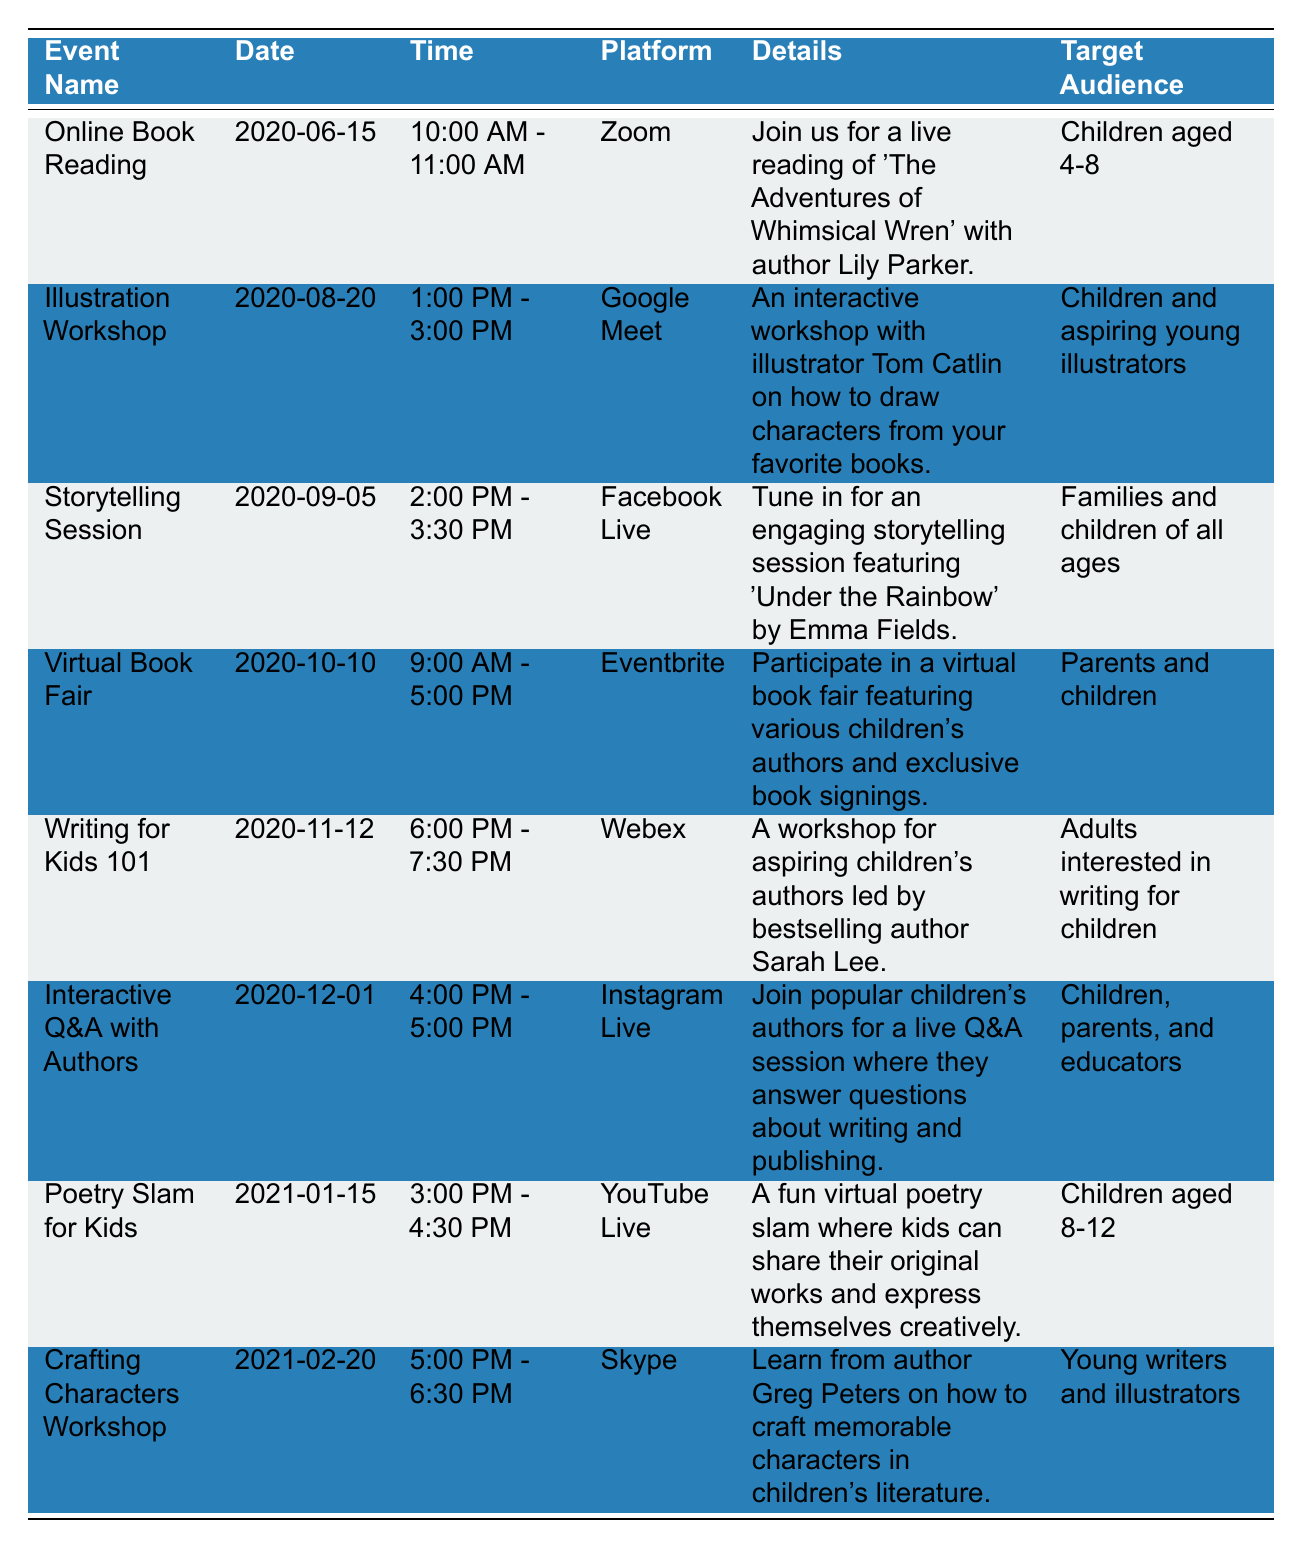What is the date of the Online Book Reading event? The table lists the Online Book Reading event under the Date column, showing the date as 2020-06-15.
Answer: 2020-06-15 How long is the Illustration Workshop scheduled to last? The time for the Illustration Workshop is from 1:00 PM to 3:00 PM, which is a duration of 2 hours.
Answer: 2 hours Which platform is used for the Interactive Q&A with Authors? The platform for the Interactive Q&A with Authors is listed as Instagram Live in the table.
Answer: Instagram Live Is the Poetry Slam for Kids event targeted towards children aged 8-12? Yes, the target audience for the Poetry Slam for Kids is specified as Children aged 8-12 in the table.
Answer: Yes How many events are scheduled for families and children of all ages? The table shows that there is one event specifically targeted at families and children of all ages, which is the Storytelling Session on 2020-09-05.
Answer: 1 Which event has the longest duration, and what is that duration? The Virtual Book Fair lasts from 9:00 AM to 5:00 PM, which totals 8 hours. Comparing this with other durations, 8 hours is the longest.
Answer: Virtual Book Fair, 8 hours How many authors are involved in the Writing for Kids 101 workshop? The Writing for Kids 101 workshop is led by one bestselling author, Sarah Lee, as indicated in the details column.
Answer: 1 Are there any events scheduled after January 15, 2021? Yes, there is one event, the Crafting Characters Workshop scheduled for February 20, 2021.
Answer: Yes What is the average duration of all listed events? To find the average, we must convert the event durations: Online Book Reading (1 hour), Illustration Workshop (2 hours), Storytelling Session (1.5 hours), Virtual Book Fair (8 hours), Writing for Kids 101 (1.5 hours), Interactive Q&A (1 hour), Poetry Slam (1.5 hours), and Crafting Characters (1.5 hours). Adding them gives 17 hours total, divided by 8 events equals an average of 2.125 hours.
Answer: 2.125 hours 